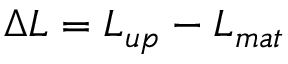Convert formula to latex. <formula><loc_0><loc_0><loc_500><loc_500>\Delta L = L _ { u p } - L _ { m a t }</formula> 